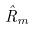Convert formula to latex. <formula><loc_0><loc_0><loc_500><loc_500>\hat { R } _ { m }</formula> 